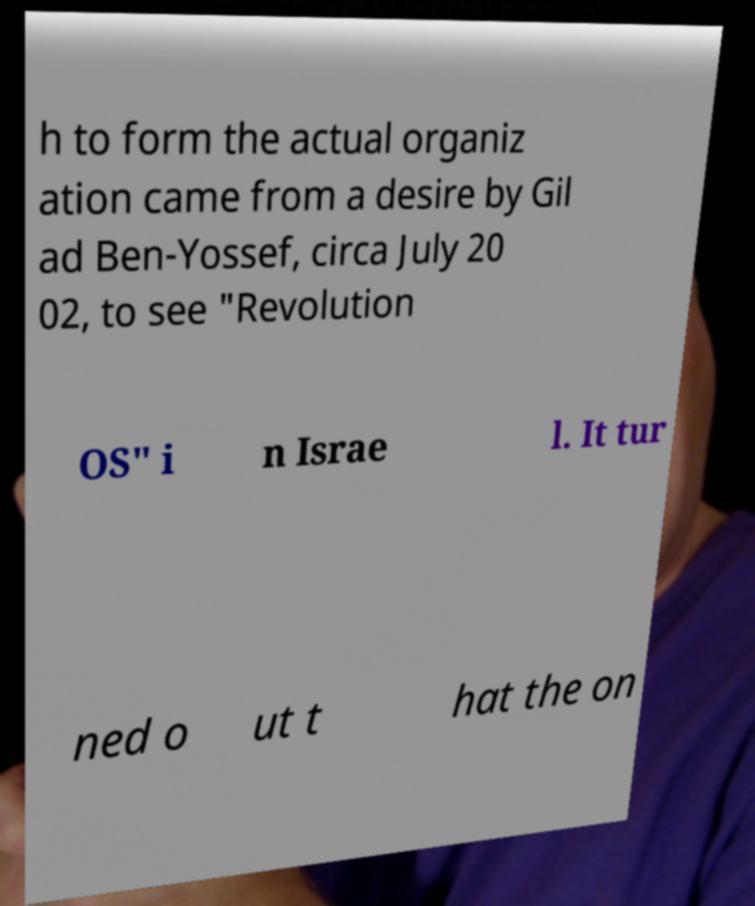Could you extract and type out the text from this image? h to form the actual organiz ation came from a desire by Gil ad Ben-Yossef, circa July 20 02, to see "Revolution OS" i n Israe l. It tur ned o ut t hat the on 